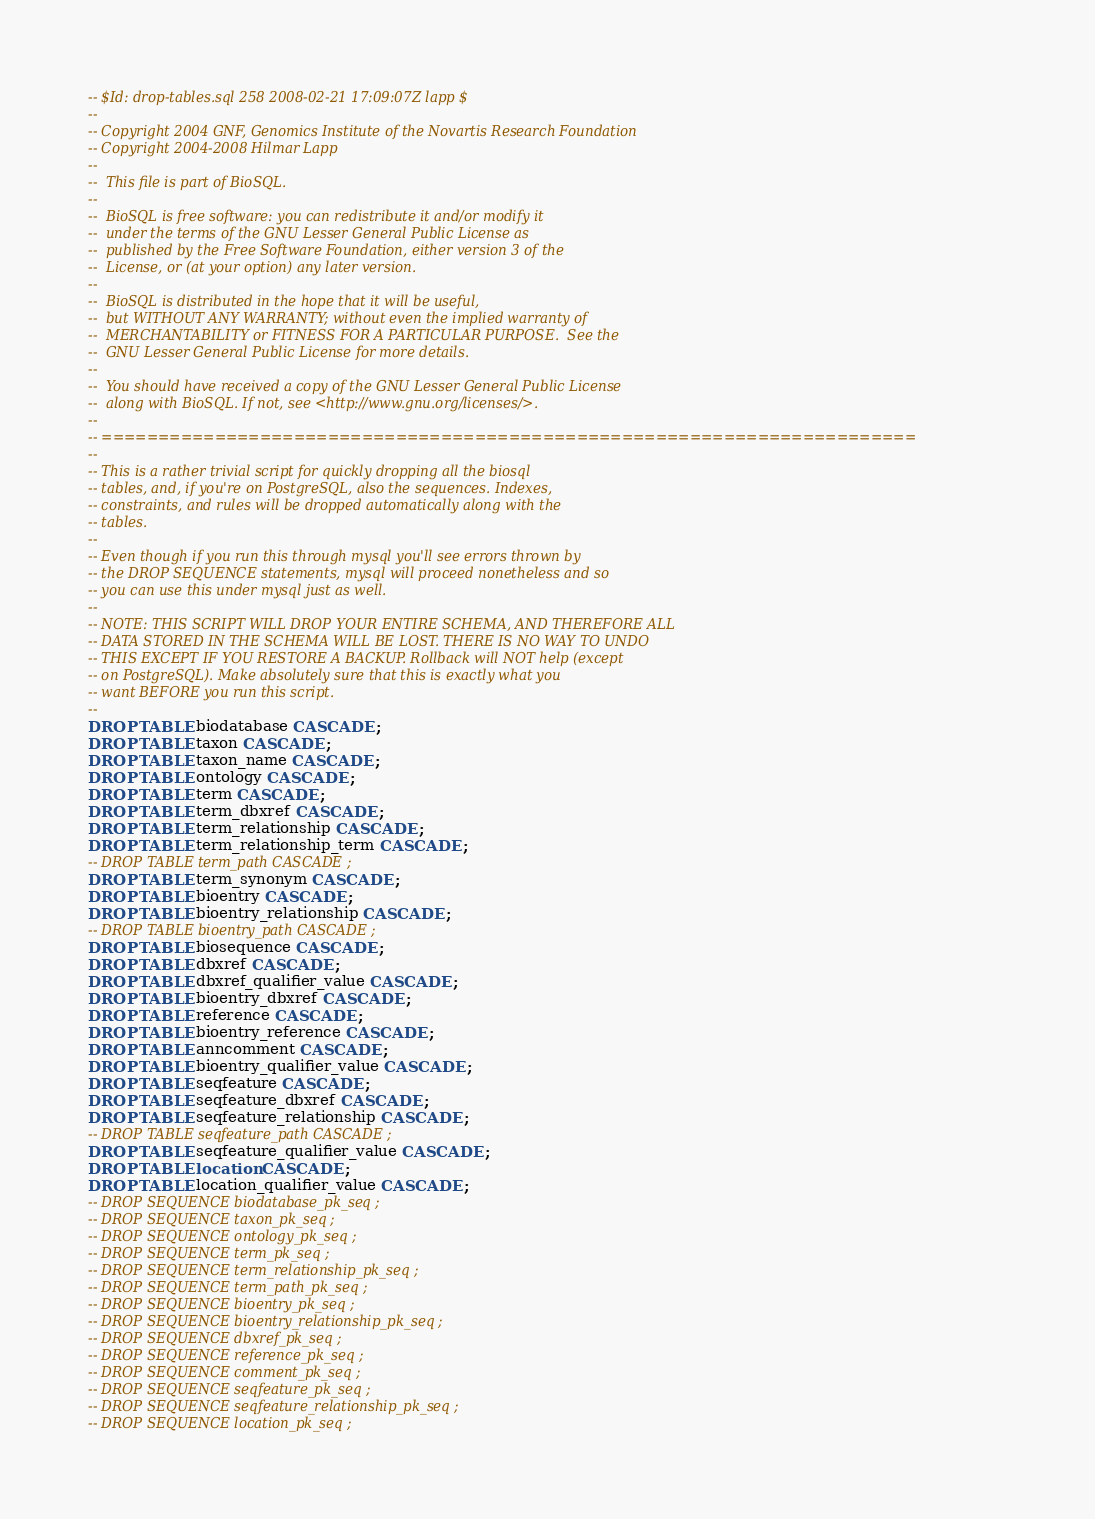Convert code to text. <code><loc_0><loc_0><loc_500><loc_500><_SQL_>-- $Id: drop-tables.sql 258 2008-02-21 17:09:07Z lapp $ 
--
-- Copyright 2004 GNF, Genomics Institute of the Novartis Research Foundation
-- Copyright 2004-2008 Hilmar Lapp
-- 
--  This file is part of BioSQL.
--
--  BioSQL is free software: you can redistribute it and/or modify it
--  under the terms of the GNU Lesser General Public License as
--  published by the Free Software Foundation, either version 3 of the
--  License, or (at your option) any later version.
--
--  BioSQL is distributed in the hope that it will be useful,
--  but WITHOUT ANY WARRANTY; without even the implied warranty of
--  MERCHANTABILITY or FITNESS FOR A PARTICULAR PURPOSE.  See the
--  GNU Lesser General Public License for more details.
--
--  You should have received a copy of the GNU Lesser General Public License
--  along with BioSQL. If not, see <http://www.gnu.org/licenses/>.
--
-- ========================================================================
--
-- This is a rather trivial script for quickly dropping all the biosql
-- tables, and, if you're on PostgreSQL, also the sequences. Indexes,
-- constraints, and rules will be dropped automatically along with the
-- tables.
--
-- Even though if you run this through mysql you'll see errors thrown by
-- the DROP SEQUENCE statements, mysql will proceed nonetheless and so
-- you can use this under mysql just as well.
--
-- NOTE: THIS SCRIPT WILL DROP YOUR ENTIRE SCHEMA, AND THEREFORE ALL
-- DATA STORED IN THE SCHEMA WILL BE LOST. THERE IS NO WAY TO UNDO
-- THIS EXCEPT IF YOU RESTORE A BACKUP. Rollback will NOT help (except
-- on PostgreSQL). Make absolutely sure that this is exactly what you
-- want BEFORE you run this script.
--
DROP TABLE biodatabase CASCADE ;
DROP TABLE taxon CASCADE ;
DROP TABLE taxon_name CASCADE ;
DROP TABLE ontology CASCADE ;
DROP TABLE term CASCADE ;
DROP TABLE term_dbxref CASCADE ;
DROP TABLE term_relationship CASCADE ;
DROP TABLE term_relationship_term CASCADE ;
-- DROP TABLE term_path CASCADE ;
DROP TABLE term_synonym CASCADE ;
DROP TABLE bioentry CASCADE ;
DROP TABLE bioentry_relationship CASCADE ;
-- DROP TABLE bioentry_path CASCADE ;
DROP TABLE biosequence CASCADE ;
DROP TABLE dbxref CASCADE ;
DROP TABLE dbxref_qualifier_value CASCADE ;
DROP TABLE bioentry_dbxref CASCADE ; 
DROP TABLE reference CASCADE ;
DROP TABLE bioentry_reference CASCADE ;
DROP TABLE anncomment CASCADE ;
DROP TABLE bioentry_qualifier_value CASCADE ;
DROP TABLE seqfeature CASCADE ;
DROP TABLE seqfeature_dbxref CASCADE ;
DROP TABLE seqfeature_relationship CASCADE ;
-- DROP TABLE seqfeature_path CASCADE ;
DROP TABLE seqfeature_qualifier_value CASCADE ;
DROP TABLE location CASCADE ;
DROP TABLE location_qualifier_value CASCADE ;
-- DROP SEQUENCE biodatabase_pk_seq ;
-- DROP SEQUENCE taxon_pk_seq ;
-- DROP SEQUENCE ontology_pk_seq ;
-- DROP SEQUENCE term_pk_seq ;
-- DROP SEQUENCE term_relationship_pk_seq ;
-- DROP SEQUENCE term_path_pk_seq ;
-- DROP SEQUENCE bioentry_pk_seq ;
-- DROP SEQUENCE bioentry_relationship_pk_seq ;
-- DROP SEQUENCE dbxref_pk_seq ;
-- DROP SEQUENCE reference_pk_seq ;
-- DROP SEQUENCE comment_pk_seq ;
-- DROP SEQUENCE seqfeature_pk_seq ;
-- DROP SEQUENCE seqfeature_relationship_pk_seq ;
-- DROP SEQUENCE location_pk_seq ;


</code> 